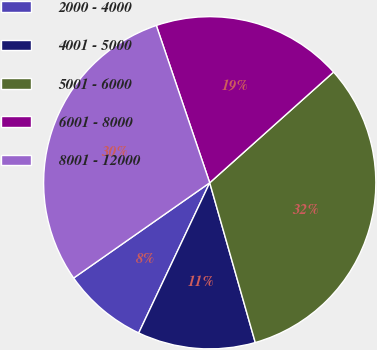<chart> <loc_0><loc_0><loc_500><loc_500><pie_chart><fcel>2000 - 4000<fcel>4001 - 5000<fcel>5001 - 6000<fcel>6001 - 8000<fcel>8001 - 12000<nl><fcel>8.25%<fcel>11.45%<fcel>32.19%<fcel>18.6%<fcel>29.51%<nl></chart> 